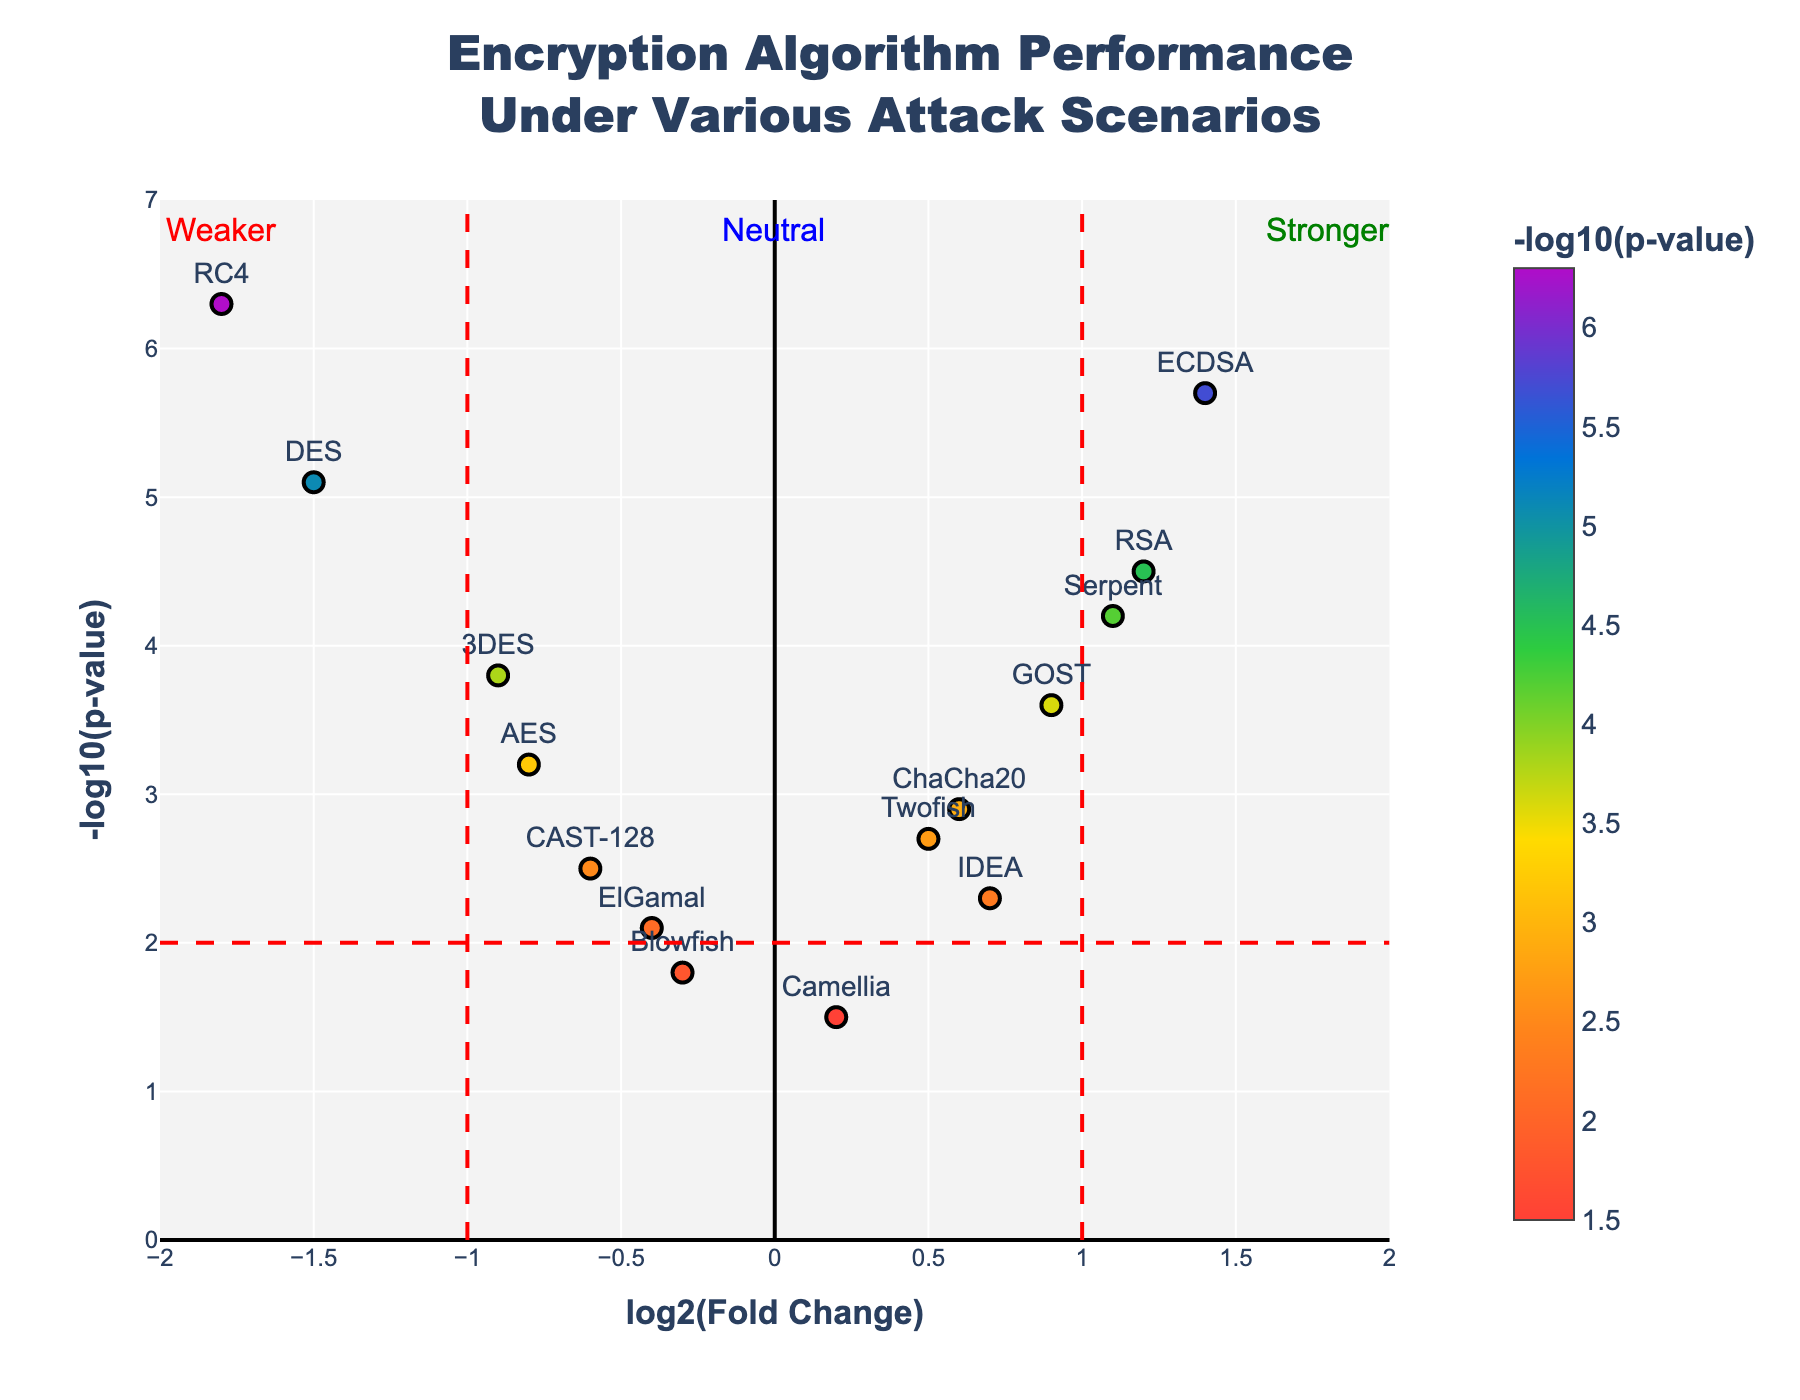What is the title of the figure? The title can be found at the top of the figure. It is usually in a larger font size and centered.
Answer: Encryption Algorithm Performance Under Various Attack Scenarios Which algorithm shows the highest performance boost (highest log2(fold change))? Look for the data point with the highest log2(fold change) value on the x-axis.
Answer: ECDSA Which data point represents the weakest performance under attack? Identify the data point with the most negative log2(fold change) value.
Answer: RC4 How many algorithms have a log2(fold change) value greater than 0? Count the number of data points to the right of the y-axis (log2(fold change) greater than 0).
Answer: 7 What is the significance level threshold indicated in the figure? Identify the horizontal red dashed line and its y-coordinate. This line represents the threshold for the -log10(p-value).
Answer: 2 Which algorithm has the highest -log10(p-value) and what is its value? Look for the data point with the highest y-value on the y-axis.
Answer: RC4, 6.3 Compare AES and RSA. Which one has a higher performance increase and greater significance level under attack? Compare both algorithms' x and y values. RSA has higher log2(fold change) and -log10(p-value) values than AES.
Answer: RSA Identify algorithms that have both a positive log2(fold change) and a -log10(p-value) below 2. Find data points to the right of the y-axis and below the horizontal dashed line.
Answer: Twofish, IDEA, Camellia Calculate the average -log10(p-value) for algorithms with negative log2(fold change). Sum the -log10(p-value) of data points left of the y-axis and divide by the number of such points.
Answer: (3.2 + 1.8 + 5.1 + 3.8 + 6.3 + 2.1 + 2.5) / 7 = 3.685 